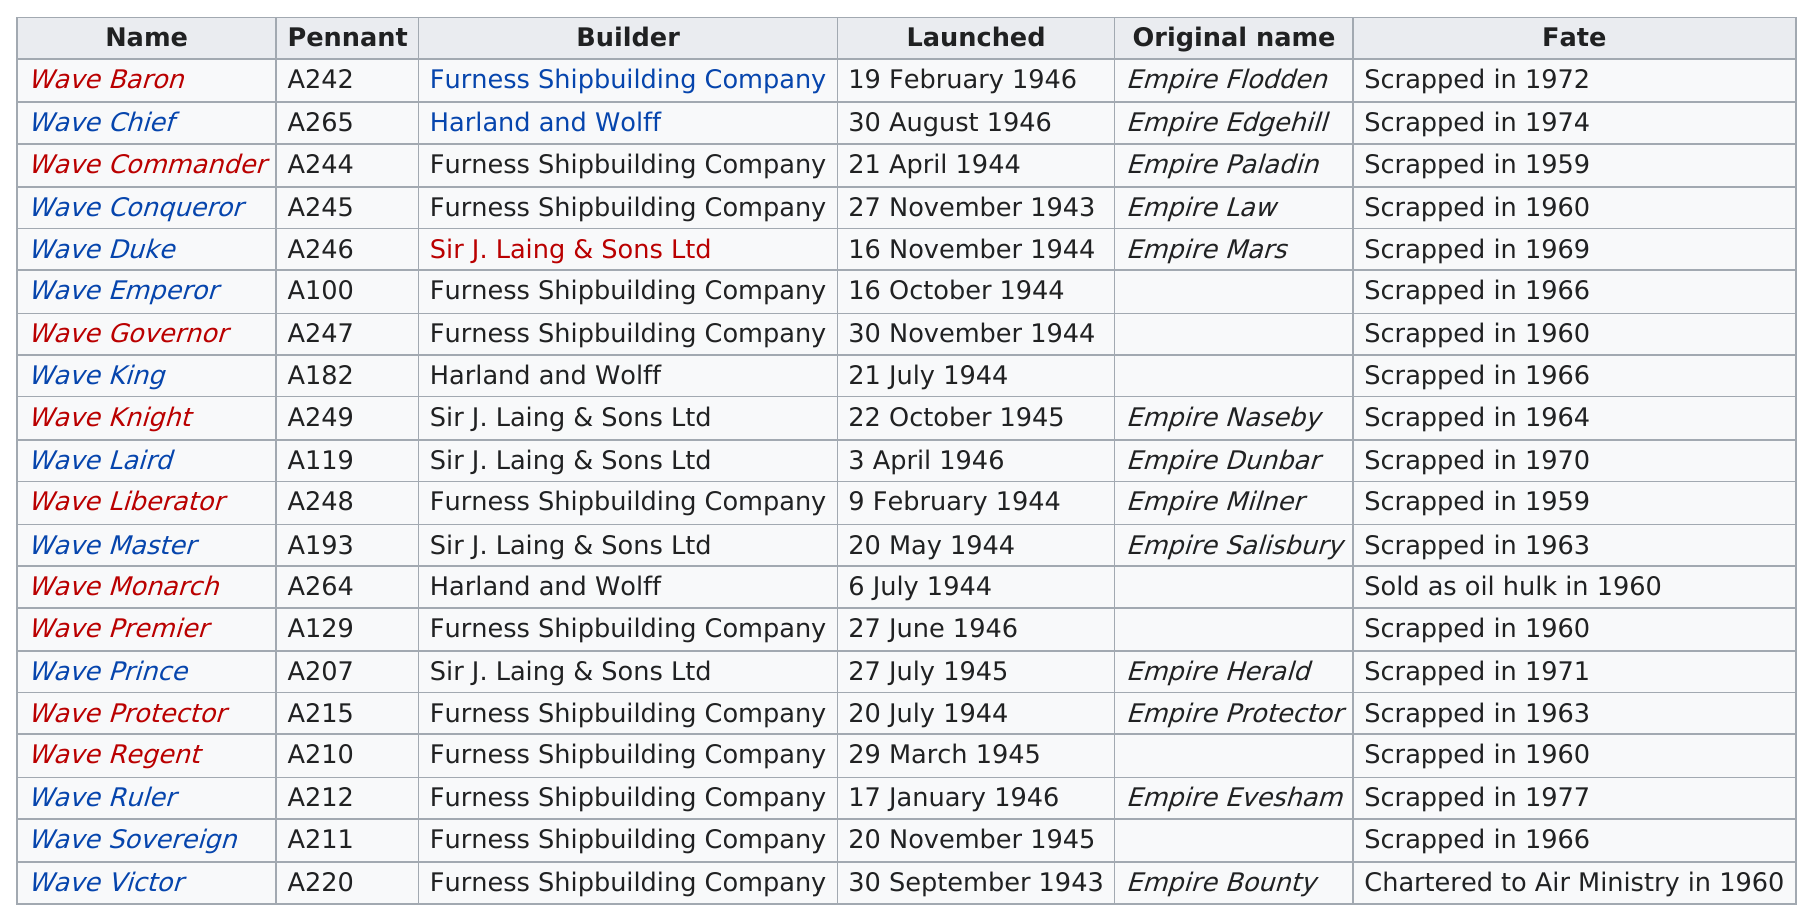Identify some key points in this picture. Immediately following the launch of the Wave Emperor class oiler, the Wave Duke class was the next in production. The first ship was launched on September 30, 1943. A total of 18 ships were scrapped. The name of the last ship that was scrapped is Wave Ruler. During the year 1944, a significant number of ships were launched. Specifically, 9 ships were launched in that year. 